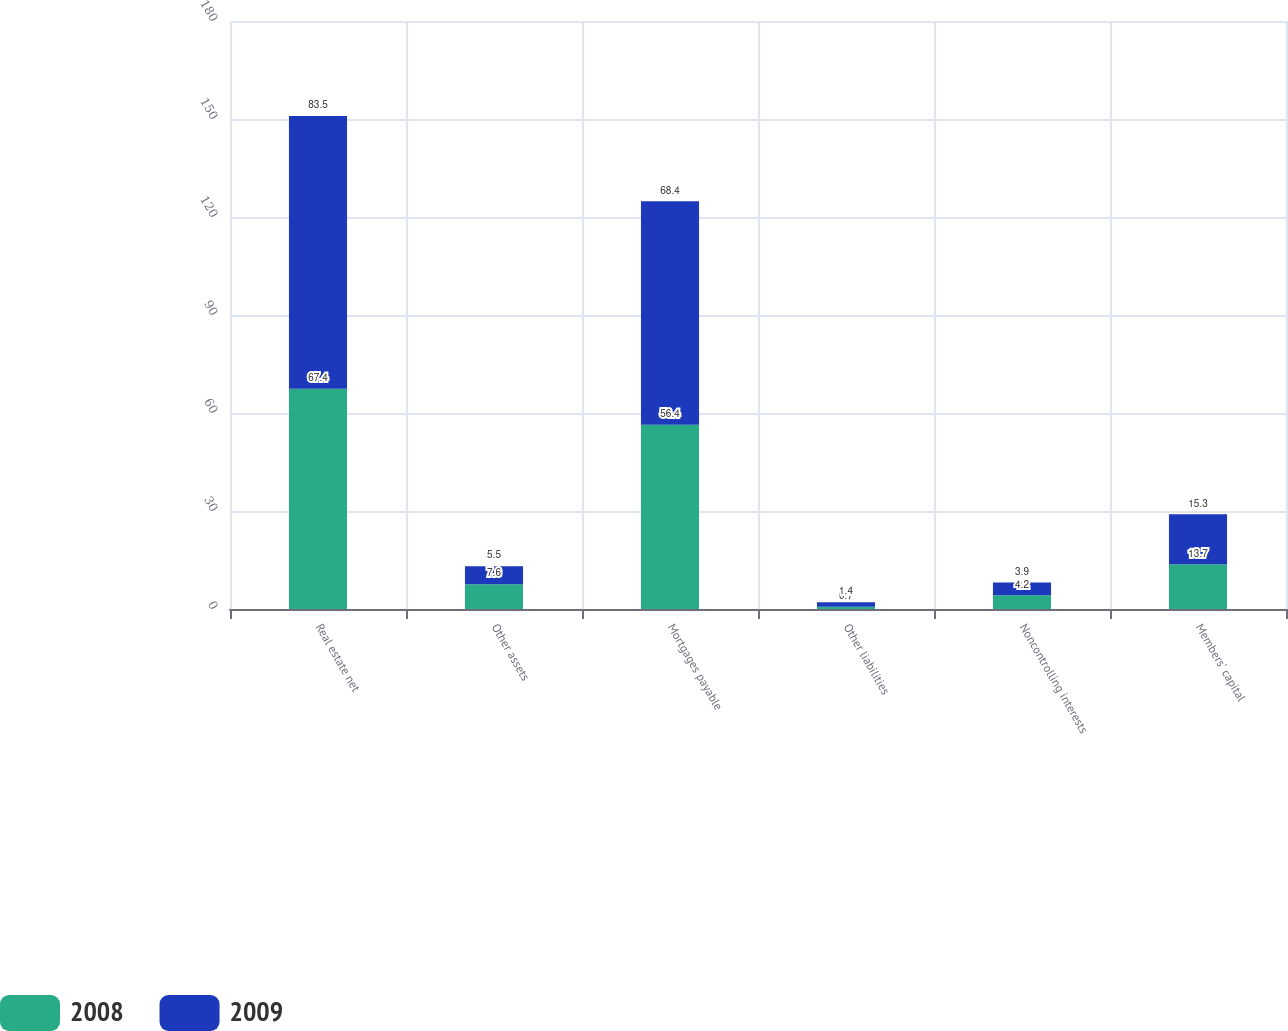Convert chart. <chart><loc_0><loc_0><loc_500><loc_500><stacked_bar_chart><ecel><fcel>Real estate net<fcel>Other assets<fcel>Mortgages payable<fcel>Other liabilities<fcel>Noncontrolling interests<fcel>Members' capital<nl><fcel>2008<fcel>67.4<fcel>7.6<fcel>56.4<fcel>0.7<fcel>4.2<fcel>13.7<nl><fcel>2009<fcel>83.5<fcel>5.5<fcel>68.4<fcel>1.4<fcel>3.9<fcel>15.3<nl></chart> 